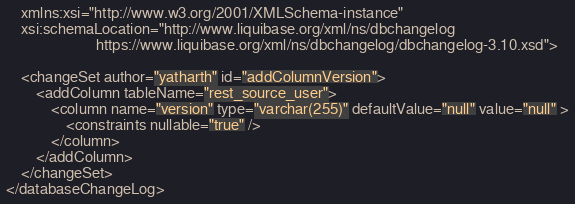Convert code to text. <code><loc_0><loc_0><loc_500><loc_500><_XML_>    xmlns:xsi="http://www.w3.org/2001/XMLSchema-instance"
    xsi:schemaLocation="http://www.liquibase.org/xml/ns/dbchangelog
                        https://www.liquibase.org/xml/ns/dbchangelog/dbchangelog-3.10.xsd">

    <changeSet author="yatharth" id="addColumnVersion">
        <addColumn tableName="rest_source_user">
            <column name="version" type="varchar(255)" defaultValue="null" value="null" >
                <constraints nullable="true" />
            </column>
        </addColumn>
    </changeSet>
</databaseChangeLog>
</code> 